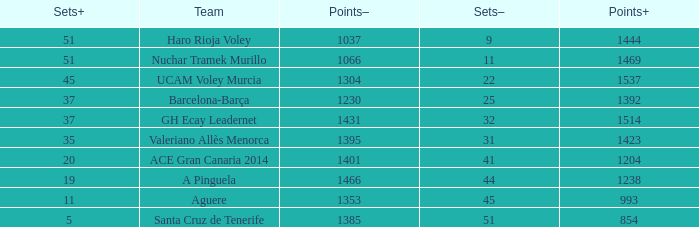What is the total number of Points- when the Sets- is larger than 51? 0.0. 